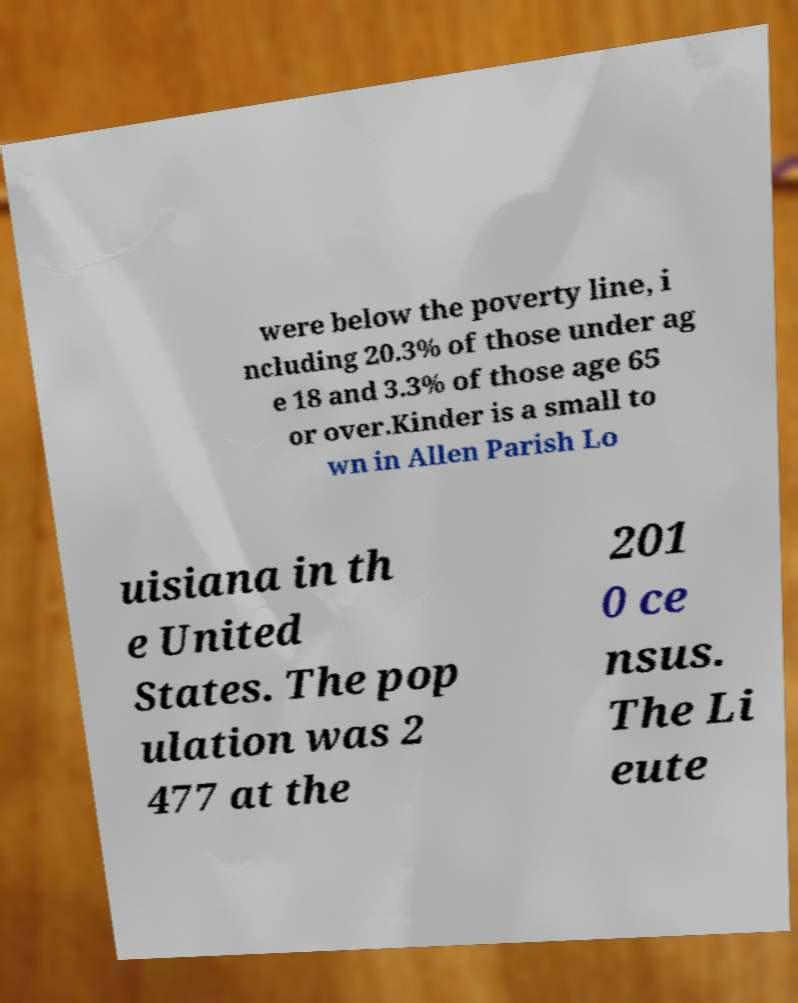Can you read and provide the text displayed in the image?This photo seems to have some interesting text. Can you extract and type it out for me? were below the poverty line, i ncluding 20.3% of those under ag e 18 and 3.3% of those age 65 or over.Kinder is a small to wn in Allen Parish Lo uisiana in th e United States. The pop ulation was 2 477 at the 201 0 ce nsus. The Li eute 